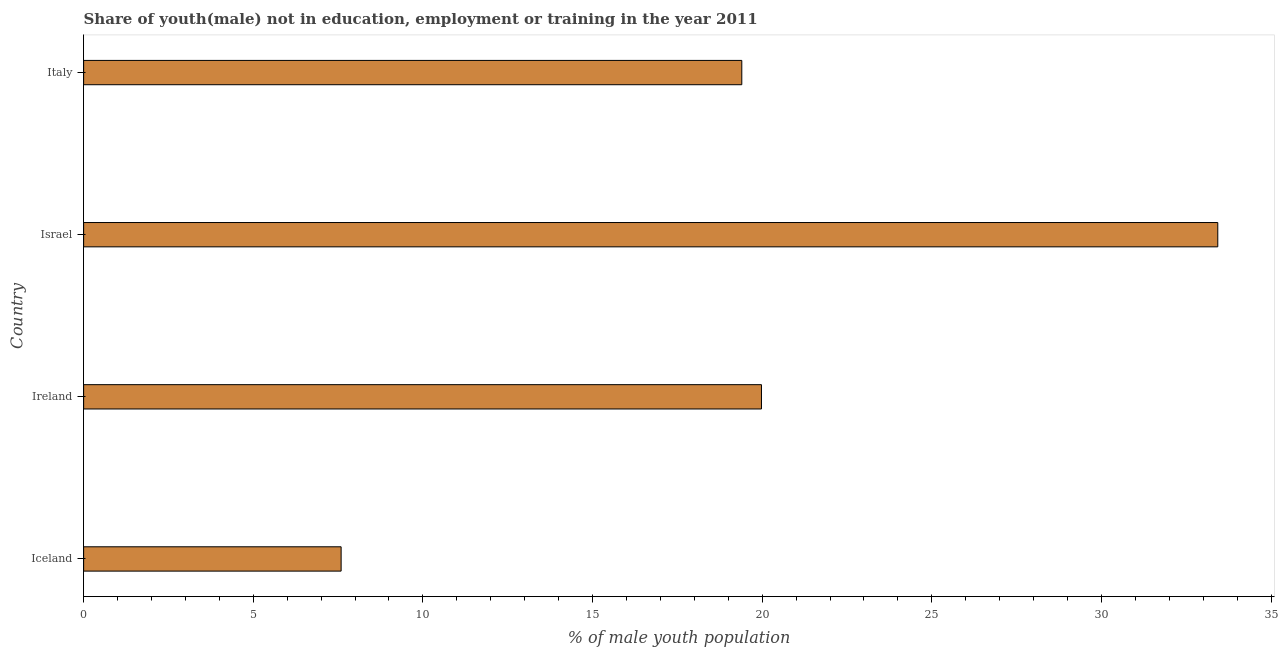Does the graph contain grids?
Keep it short and to the point. No. What is the title of the graph?
Provide a succinct answer. Share of youth(male) not in education, employment or training in the year 2011. What is the label or title of the X-axis?
Make the answer very short. % of male youth population. What is the label or title of the Y-axis?
Your answer should be very brief. Country. What is the unemployed male youth population in Iceland?
Give a very brief answer. 7.59. Across all countries, what is the maximum unemployed male youth population?
Offer a terse response. 33.43. Across all countries, what is the minimum unemployed male youth population?
Provide a short and direct response. 7.59. What is the sum of the unemployed male youth population?
Make the answer very short. 80.4. What is the difference between the unemployed male youth population in Ireland and Italy?
Provide a succinct answer. 0.58. What is the average unemployed male youth population per country?
Provide a succinct answer. 20.1. What is the median unemployed male youth population?
Provide a succinct answer. 19.69. What is the ratio of the unemployed male youth population in Iceland to that in Israel?
Offer a terse response. 0.23. What is the difference between the highest and the second highest unemployed male youth population?
Offer a very short reply. 13.45. Is the sum of the unemployed male youth population in Israel and Italy greater than the maximum unemployed male youth population across all countries?
Your response must be concise. Yes. What is the difference between the highest and the lowest unemployed male youth population?
Offer a terse response. 25.84. In how many countries, is the unemployed male youth population greater than the average unemployed male youth population taken over all countries?
Keep it short and to the point. 1. How many bars are there?
Offer a very short reply. 4. How many countries are there in the graph?
Your response must be concise. 4. Are the values on the major ticks of X-axis written in scientific E-notation?
Ensure brevity in your answer.  No. What is the % of male youth population of Iceland?
Make the answer very short. 7.59. What is the % of male youth population in Ireland?
Your answer should be very brief. 19.98. What is the % of male youth population of Israel?
Make the answer very short. 33.43. What is the % of male youth population of Italy?
Offer a very short reply. 19.4. What is the difference between the % of male youth population in Iceland and Ireland?
Ensure brevity in your answer.  -12.39. What is the difference between the % of male youth population in Iceland and Israel?
Your answer should be compact. -25.84. What is the difference between the % of male youth population in Iceland and Italy?
Provide a short and direct response. -11.81. What is the difference between the % of male youth population in Ireland and Israel?
Offer a very short reply. -13.45. What is the difference between the % of male youth population in Ireland and Italy?
Your answer should be very brief. 0.58. What is the difference between the % of male youth population in Israel and Italy?
Provide a succinct answer. 14.03. What is the ratio of the % of male youth population in Iceland to that in Ireland?
Your answer should be compact. 0.38. What is the ratio of the % of male youth population in Iceland to that in Israel?
Provide a short and direct response. 0.23. What is the ratio of the % of male youth population in Iceland to that in Italy?
Ensure brevity in your answer.  0.39. What is the ratio of the % of male youth population in Ireland to that in Israel?
Your response must be concise. 0.6. What is the ratio of the % of male youth population in Ireland to that in Italy?
Your response must be concise. 1.03. What is the ratio of the % of male youth population in Israel to that in Italy?
Give a very brief answer. 1.72. 